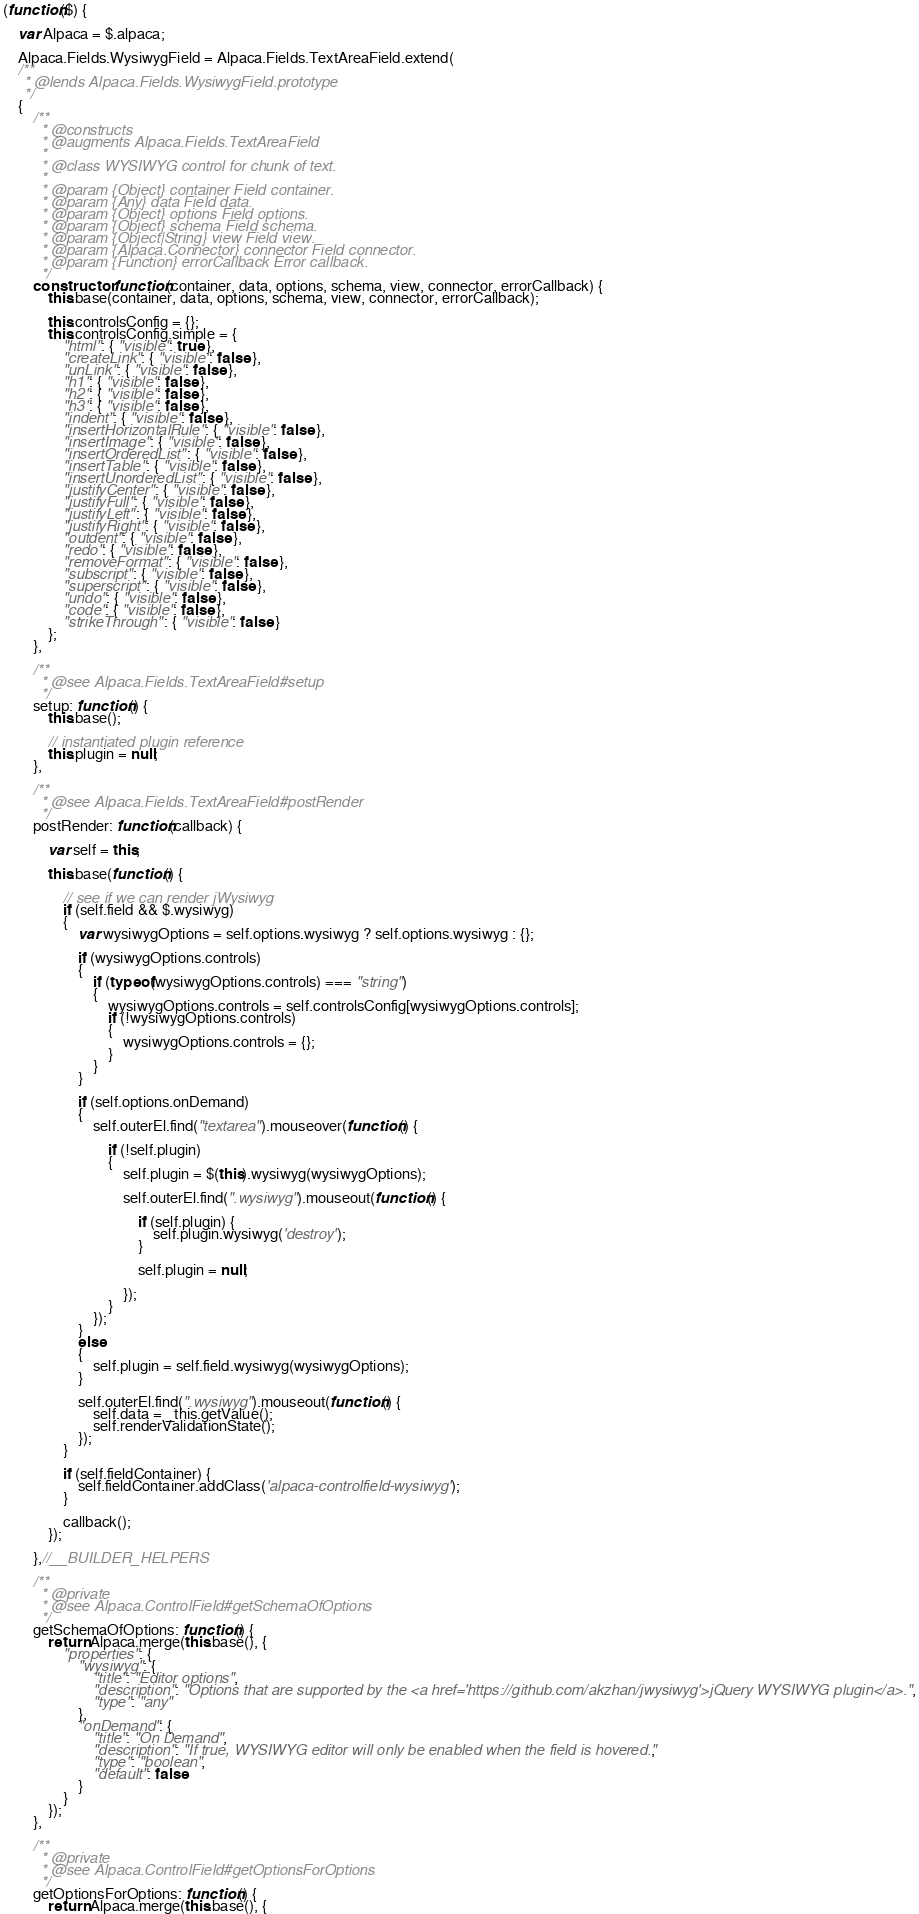<code> <loc_0><loc_0><loc_500><loc_500><_JavaScript_>(function($) {

    var Alpaca = $.alpaca;

    Alpaca.Fields.WysiwygField = Alpaca.Fields.TextAreaField.extend(
    /**
     * @lends Alpaca.Fields.WysiwygField.prototype
     */
    {
        /**
         * @constructs
         * @augments Alpaca.Fields.TextAreaField
         *
         * @class WYSIWYG control for chunk of text.
         *
         * @param {Object} container Field container.
         * @param {Any} data Field data.
         * @param {Object} options Field options.
         * @param {Object} schema Field schema.
         * @param {Object|String} view Field view.
         * @param {Alpaca.Connector} connector Field connector.
         * @param {Function} errorCallback Error callback.
         */
        constructor: function(container, data, options, schema, view, connector, errorCallback) {
            this.base(container, data, options, schema, view, connector, errorCallback);

            this.controlsConfig = {};
            this.controlsConfig.simple = {
                "html": { "visible": true },
                "createLink": { "visible": false },
                "unLink": { "visible": false },
                "h1": { "visible": false },
                "h2": { "visible": false },
                "h3": { "visible": false },
                "indent": { "visible": false },
                "insertHorizontalRule": { "visible": false },
                "insertImage": { "visible": false },
                "insertOrderedList": { "visible": false },
                "insertTable": { "visible": false },
                "insertUnorderedList": { "visible": false },
                "justifyCenter": { "visible": false },
                "justifyFull": { "visible": false },
                "justifyLeft": { "visible": false },
                "justifyRight": { "visible": false },
                "outdent": { "visible": false },
                "redo": { "visible": false },
                "removeFormat": { "visible": false },
                "subscript": { "visible": false },
                "superscript": { "visible": false },
                "undo": { "visible": false },
                "code": { "visible": false },
                "strikeThrough": { "visible": false }
            };
        },

        /**
         * @see Alpaca.Fields.TextAreaField#setup
         */
        setup: function() {
            this.base();

            // instantiated plugin reference
            this.plugin = null;
        },
        
        /**
         * @see Alpaca.Fields.TextAreaField#postRender
         */
        postRender: function(callback) {

            var self = this;

            this.base(function() {

                // see if we can render jWysiwyg
                if (self.field && $.wysiwyg)
                {
                    var wysiwygOptions = self.options.wysiwyg ? self.options.wysiwyg : {};

                    if (wysiwygOptions.controls)
                    {
                        if (typeof(wysiwygOptions.controls) === "string")
                        {
                            wysiwygOptions.controls = self.controlsConfig[wysiwygOptions.controls];
                            if (!wysiwygOptions.controls)
                            {
                                wysiwygOptions.controls = {};
                            }
                        }
                    }

                    if (self.options.onDemand)
                    {
                        self.outerEl.find("textarea").mouseover(function() {

                            if (!self.plugin)
                            {
                                self.plugin = $(this).wysiwyg(wysiwygOptions);

                                self.outerEl.find(".wysiwyg").mouseout(function() {

                                    if (self.plugin) {
                                        self.plugin.wysiwyg('destroy');
                                    }

                                    self.plugin = null;

                                });
                            }
                        });
                    }
                    else
                    {
                        self.plugin = self.field.wysiwyg(wysiwygOptions);
                    }

                    self.outerEl.find(".wysiwyg").mouseout(function() {
                        self.data = _this.getValue();
                        self.renderValidationState();
                    });
                }

                if (self.fieldContainer) {
                    self.fieldContainer.addClass('alpaca-controlfield-wysiwyg');
                }

                callback();
            });

        },//__BUILDER_HELPERS
		
        /**
         * @private
         * @see Alpaca.ControlField#getSchemaOfOptions
         */
        getSchemaOfOptions: function() {
            return Alpaca.merge(this.base(), {
                "properties": {
                    "wysiwyg": {
                        "title": "Editor options",
                        "description": "Options that are supported by the <a href='https://github.com/akzhan/jwysiwyg'>jQuery WYSIWYG plugin</a>.",
                        "type": "any"
                    },
                    "onDemand": {
                        "title": "On Demand",
                        "description": "If true, WYSIWYG editor will only be enabled when the field is hovered.",
                        "type": "boolean",
                        "default": false
                    }
                }
            });
        },

        /**
         * @private
         * @see Alpaca.ControlField#getOptionsForOptions
         */
        getOptionsForOptions: function() {
            return Alpaca.merge(this.base(), {</code> 